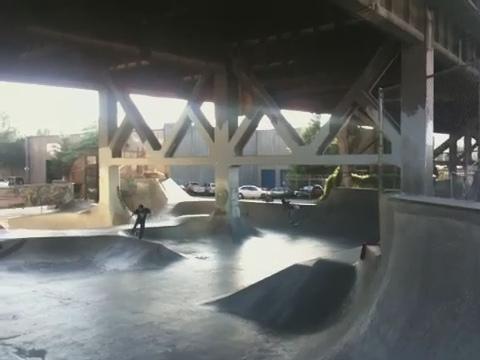Why are there mounds on the surface?
From the following set of four choices, select the accurate answer to respond to the question.
Options: For tricks, for grazing, for barriers, for gardening. For tricks. 